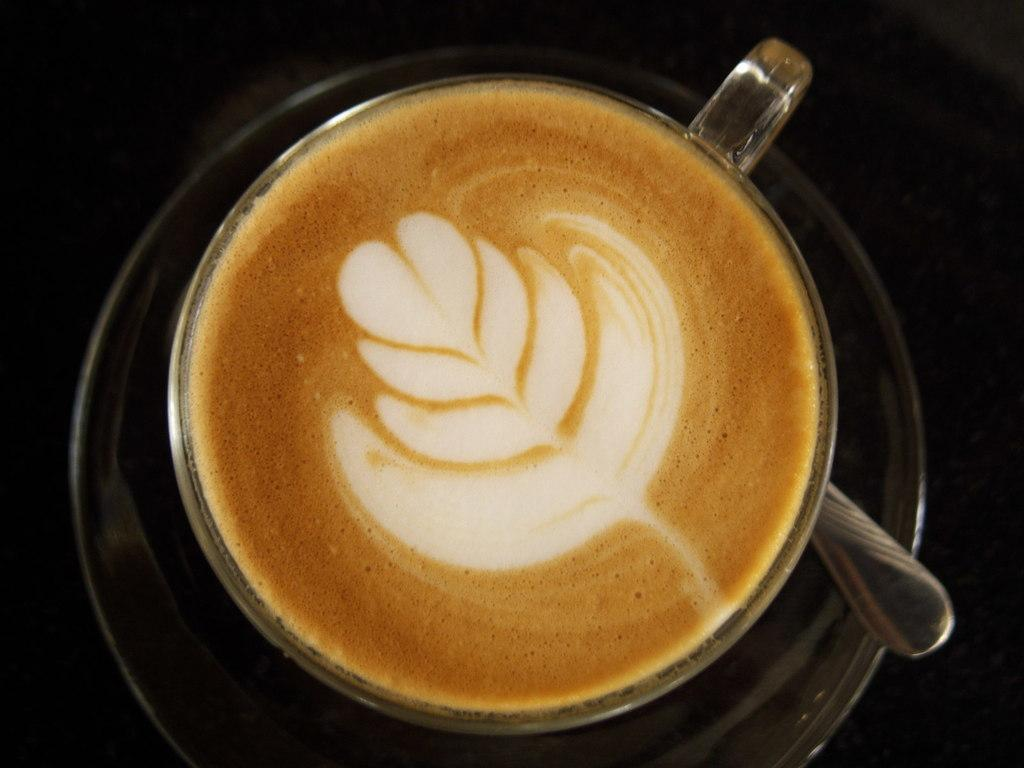What is inside the cup that is visible in the image? There is a coffee in the cup. What object is holding the coffee? There is a cup in the image. What utensil is present on the saucer? There is a spoon on the saucer. What color is the background of the image? The background of the image is black. How many bananas are hanging from the wing in the image? There is no wing or bananas present in the image. 